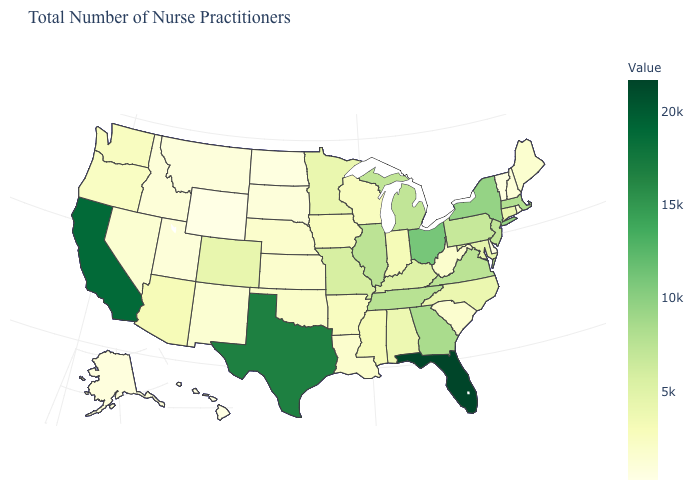Does Washington have a lower value than Wyoming?
Write a very short answer. No. Does West Virginia have the highest value in the South?
Write a very short answer. No. Is the legend a continuous bar?
Answer briefly. Yes. 